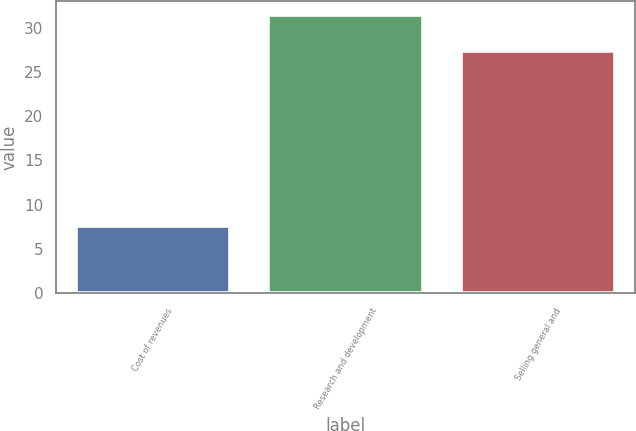Convert chart. <chart><loc_0><loc_0><loc_500><loc_500><bar_chart><fcel>Cost of revenues<fcel>Research and development<fcel>Selling general and<nl><fcel>7.6<fcel>31.4<fcel>27.4<nl></chart> 